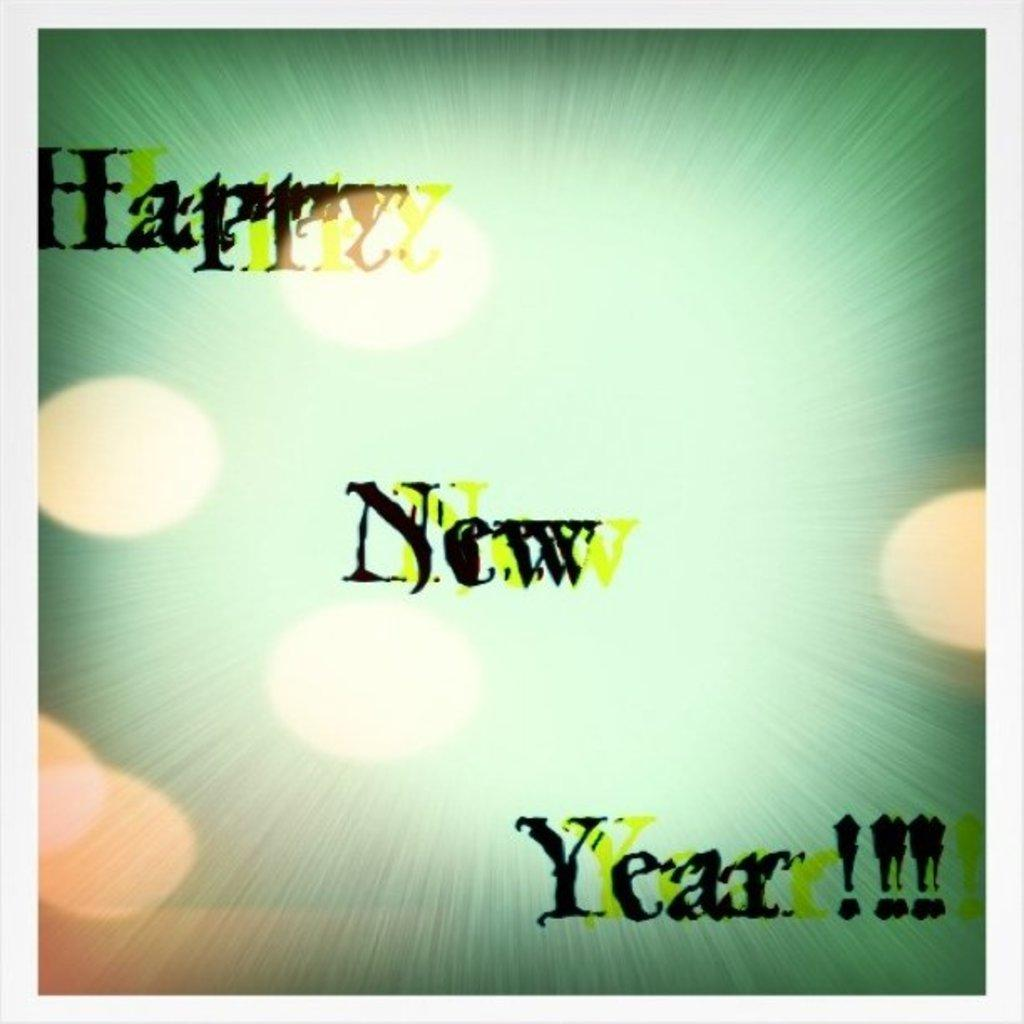<image>
Summarize the visual content of the image. A graphic featuring the phrase "Happy New Year!!!" has a green background. 